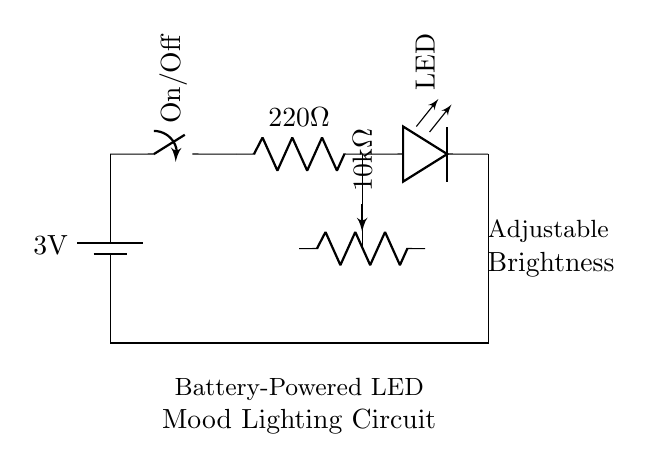What is the voltage of the battery? The battery is labeled as 3 volts in the circuit diagram. This indicates the potential difference it supplies to the circuit.
Answer: 3 volts What is the resistance of the resistor? The resistor in the circuit is labeled as 220 ohms, which is its resistance value and indicates how much it opposes the flow of current.
Answer: 220 ohms How many resistors are present in the circuit? By examining the diagram, there are two resistive components: one is the fixed resistor (220 ohms), and the other is a potentiometer (10 kilo ohms). Thus, there are two resistors.
Answer: 2 What is the purpose of the potentiometer? The potentiometer is used for adjustable brightness in the circuit, allowing the user to control the LED's brightness by changing the resistance.
Answer: Adjustable brightness What happens when the switch is turned off? Turning off the switch opens the circuit, breaking the flow of current from the battery to the LED, which results in the LED not lighting up.
Answer: LED turns off What is the total current flowing through the circuit? To find the current, we would need to use Ohm's law (current equals voltage divided by total resistance). However, this basic qualitative question illustrates the need for a multi-step calculation that isn't provided in this context, but generally, the current would depend on the resistance and voltage present.
Answer: Calculation needed What type of circuit is this? This is a low power circuit, specifically designed for low voltage applications using battery power for energy efficiency, ideal for mood lighting.
Answer: Low power circuit 